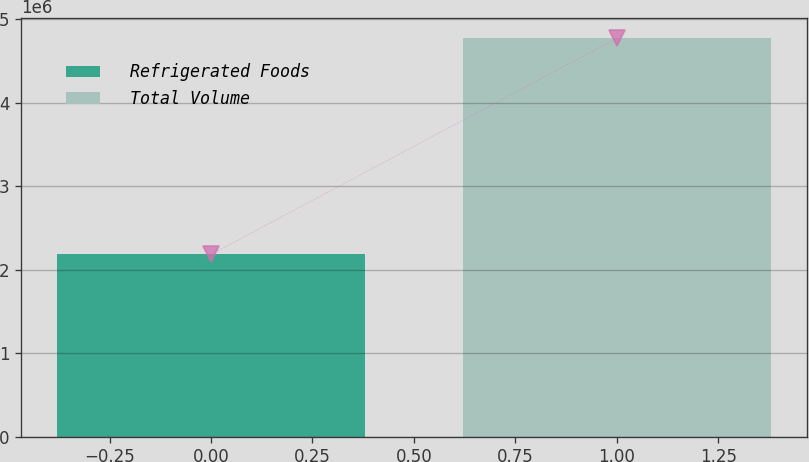<chart> <loc_0><loc_0><loc_500><loc_500><bar_chart><fcel>Refrigerated Foods<fcel>Total Volume<nl><fcel>2.18041e+06<fcel>4.77048e+06<nl></chart> 